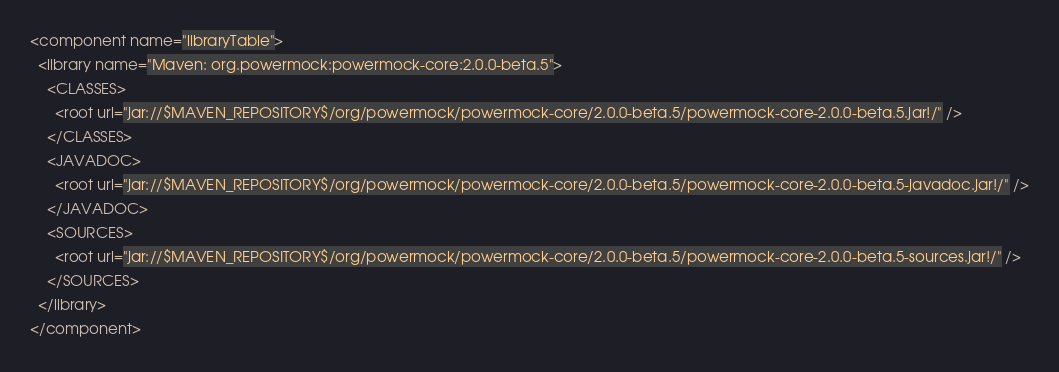<code> <loc_0><loc_0><loc_500><loc_500><_XML_><component name="libraryTable">
  <library name="Maven: org.powermock:powermock-core:2.0.0-beta.5">
    <CLASSES>
      <root url="jar://$MAVEN_REPOSITORY$/org/powermock/powermock-core/2.0.0-beta.5/powermock-core-2.0.0-beta.5.jar!/" />
    </CLASSES>
    <JAVADOC>
      <root url="jar://$MAVEN_REPOSITORY$/org/powermock/powermock-core/2.0.0-beta.5/powermock-core-2.0.0-beta.5-javadoc.jar!/" />
    </JAVADOC>
    <SOURCES>
      <root url="jar://$MAVEN_REPOSITORY$/org/powermock/powermock-core/2.0.0-beta.5/powermock-core-2.0.0-beta.5-sources.jar!/" />
    </SOURCES>
  </library>
</component></code> 